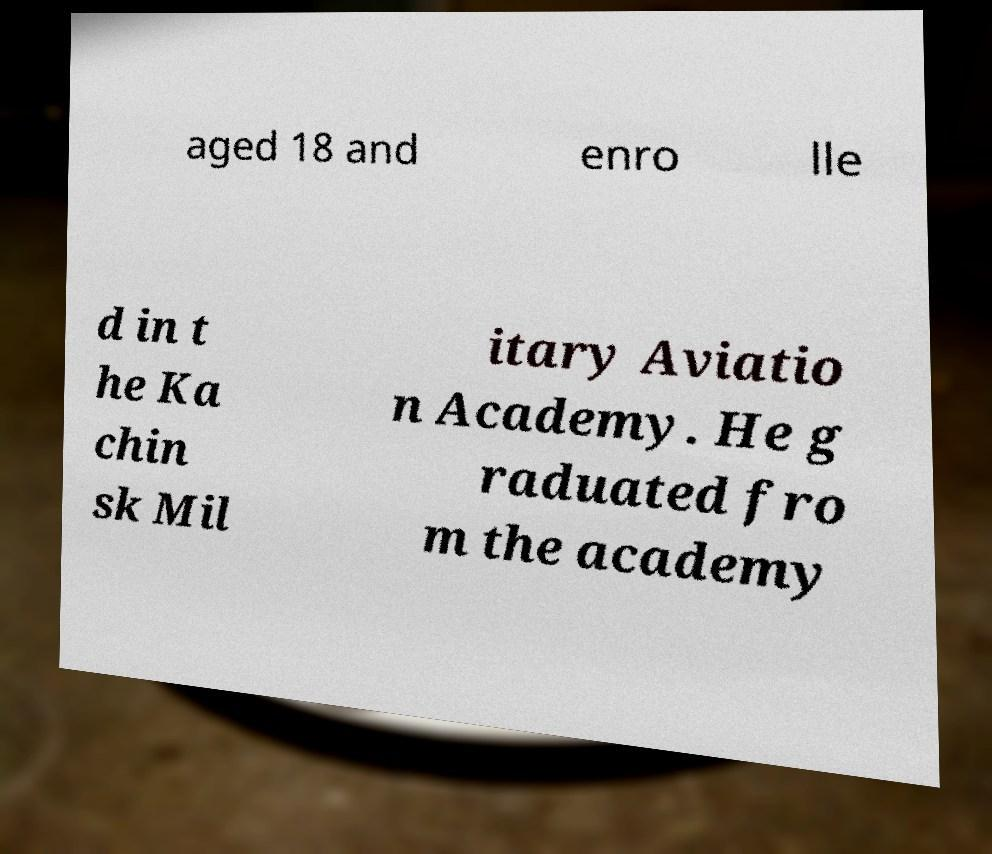I need the written content from this picture converted into text. Can you do that? aged 18 and enro lle d in t he Ka chin sk Mil itary Aviatio n Academy. He g raduated fro m the academy 